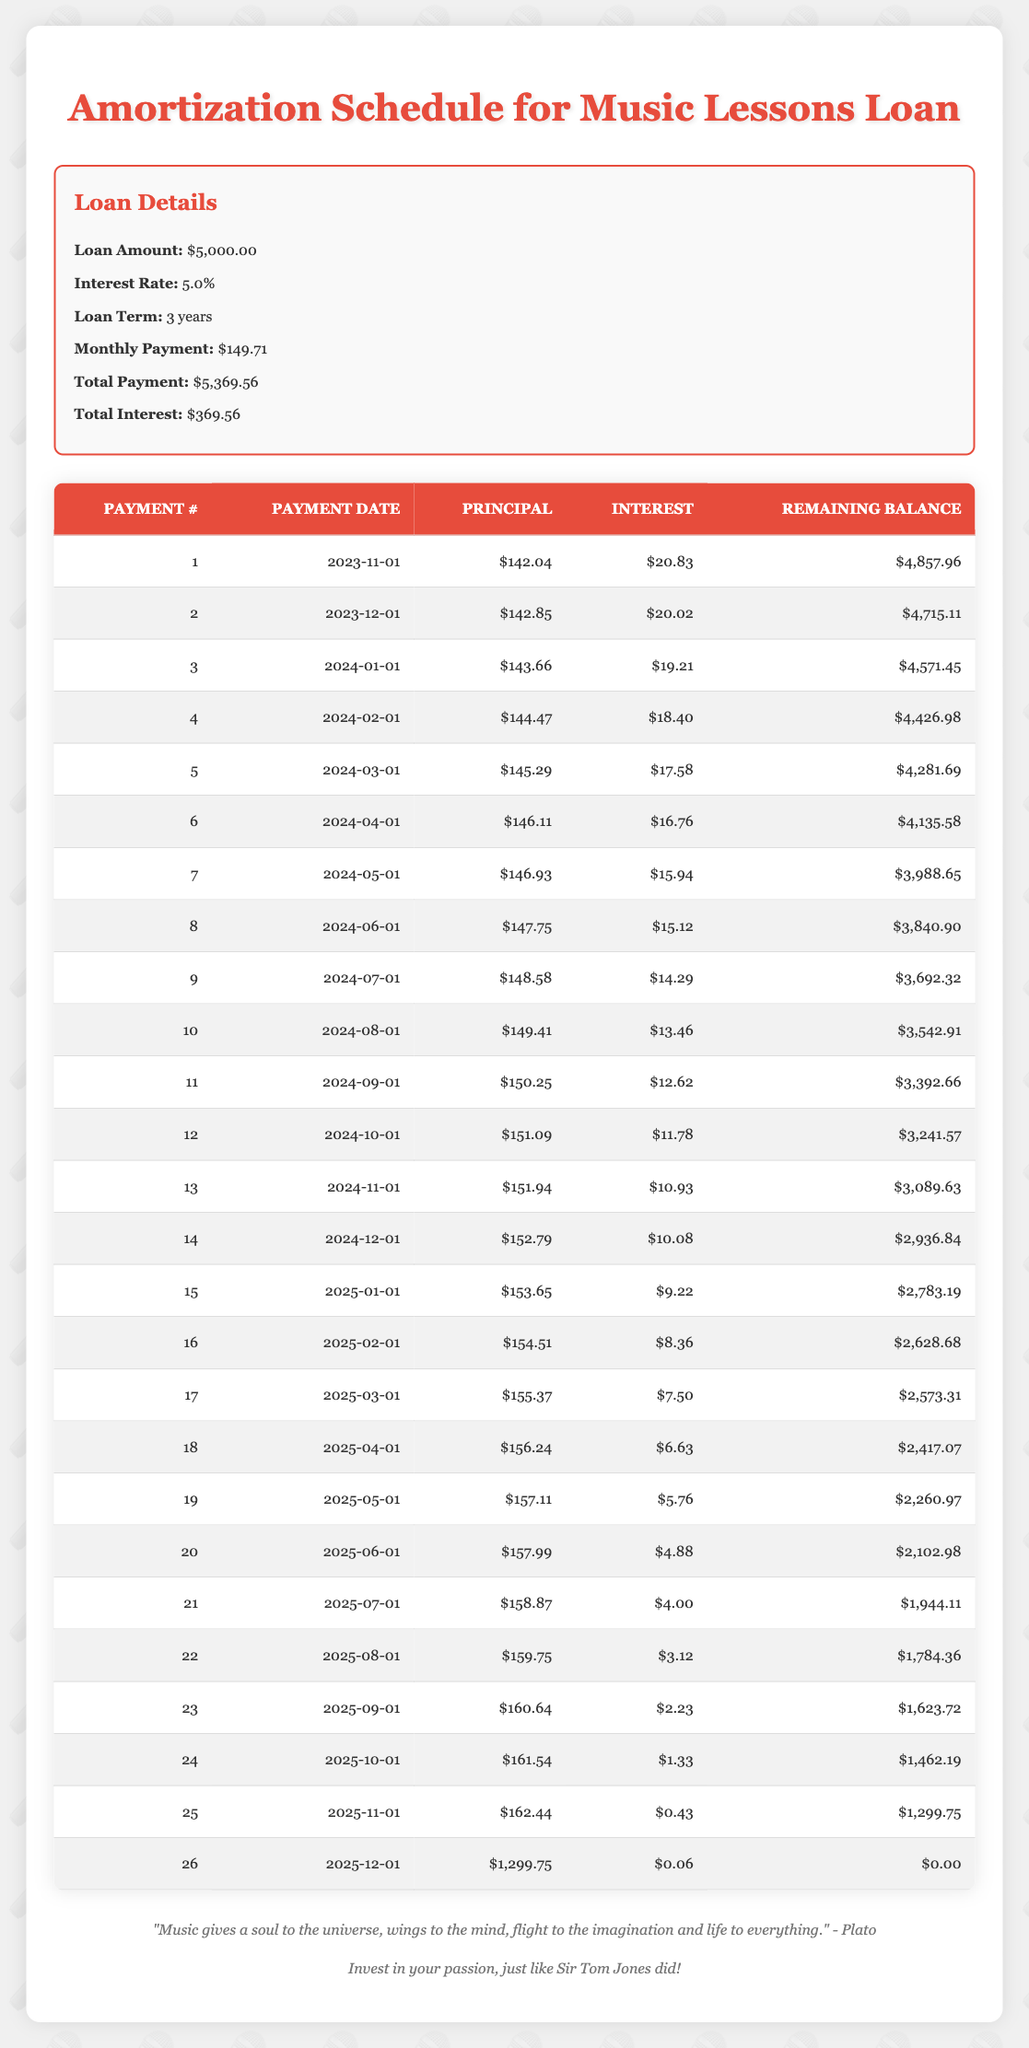What is the total interest paid over the life of the loan? The total interest over the loan term is given as $369.56 in the loan details section of the table.
Answer: 369.56 What was the remaining balance after the 5th payment? After the 5th payment listed in the table, the remaining balance is $4,281.69, as seen in the column for the remaining balance.
Answer: 4281.69 What is the monthly payment amount? The monthly payment amount is clearly stated in the loan details as $149.71.
Answer: 149.71 Is the principal payment always increasing with each payment? By examining the principal payment column, we can see that it is increasing with each payment. For instance, it started at $142.04 and reached $162.44 by the last payment.
Answer: Yes How much total does the principal reduce after the first three payments? To find the total reduction, we add the principal payments of the first three rows: $142.04 + $142.85 + $143.66 = $428.55. Thus, the principal reduces by $428.55 after the first three payments.
Answer: 428.55 What is the average interest payment for the first six payments? We will calculate the average using the interest payments for the first six months—$20.83, $20.02, $19.21, $18.40, $17.58, and $16.76. The sum is $112.80, so the average is $112.80 / 6 = $18.80.
Answer: 18.80 At what remaining balance does the last payment occur? The last payment occurs at a remaining balance of $0.00 according to the table.
Answer: 0.00 What was the principal repayment for the first payment? The principal repayment for the first payment is $142.04, as shown in the first row of the amortization schedule.
Answer: 142.04 How much did the total payment amount increase from the interest on the first payment to the last payment? The interest on the first payment is $20.83 and the interest on the last payment is $0.06. The total payment increase is $20.83 - $0.06 = $20.77.
Answer: 20.77 